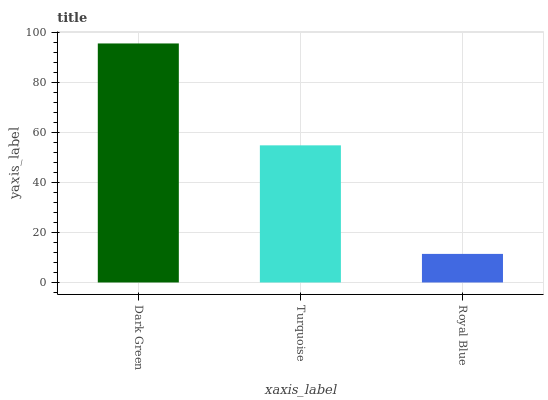Is Royal Blue the minimum?
Answer yes or no. Yes. Is Dark Green the maximum?
Answer yes or no. Yes. Is Turquoise the minimum?
Answer yes or no. No. Is Turquoise the maximum?
Answer yes or no. No. Is Dark Green greater than Turquoise?
Answer yes or no. Yes. Is Turquoise less than Dark Green?
Answer yes or no. Yes. Is Turquoise greater than Dark Green?
Answer yes or no. No. Is Dark Green less than Turquoise?
Answer yes or no. No. Is Turquoise the high median?
Answer yes or no. Yes. Is Turquoise the low median?
Answer yes or no. Yes. Is Royal Blue the high median?
Answer yes or no. No. Is Royal Blue the low median?
Answer yes or no. No. 